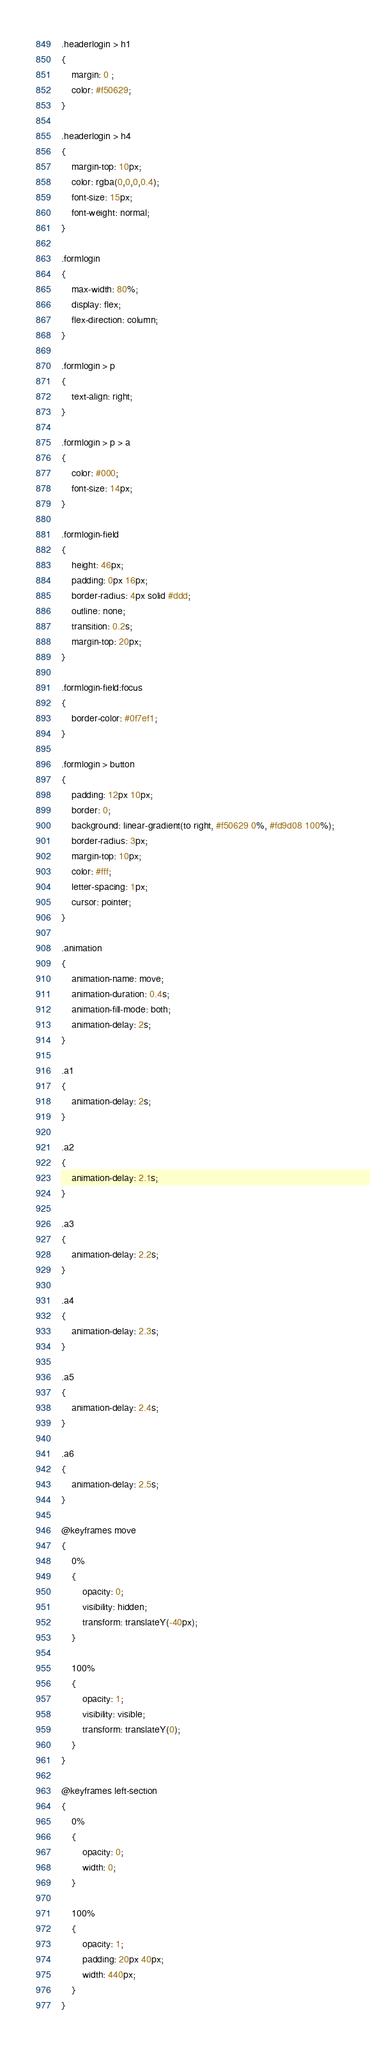<code> <loc_0><loc_0><loc_500><loc_500><_CSS_>.headerlogin > h1
{
    margin: 0 ;
    color: #f50629;
}

.headerlogin > h4 
{
    margin-top: 10px;
    color: rgba(0,0,0,0.4);
    font-size: 15px;
    font-weight: normal;
}

.formlogin
{
    max-width: 80%;
    display: flex;
    flex-direction: column;
}

.formlogin > p
{
    text-align: right;
}

.formlogin > p > a
{
    color: #000;
    font-size: 14px;
}

.formlogin-field
{
    height: 46px;
    padding: 0px 16px;
    border-radius: 4px solid #ddd;
    outline: none;
    transition: 0.2s;
    margin-top: 20px;
}

.formlogin-field:focus
{
    border-color: #0f7ef1;
}

.formlogin > button
{
    padding: 12px 10px;
    border: 0;
    background: linear-gradient(to right, #f50629 0%, #fd9d08 100%);
    border-radius: 3px;
    margin-top: 10px;
    color: #fff;
    letter-spacing: 1px;
    cursor: pointer;
}

.animation
{
    animation-name: move;
    animation-duration: 0.4s;
    animation-fill-mode: both;
    animation-delay: 2s;
}

.a1
{
    animation-delay: 2s;
}

.a2
{
    animation-delay: 2.1s;
}

.a3
{
    animation-delay: 2.2s;
}

.a4
{
    animation-delay: 2.3s;
}

.a5
{
    animation-delay: 2.4s;
}

.a6
{
    animation-delay: 2.5s;
}

@keyframes move 
{
    0%
    {
        opacity: 0;
        visibility: hidden;
        transform: translateY(-40px);
    }

    100%
    {
        opacity: 1;
        visibility: visible;
        transform: translateY(0);
    }
}

@keyframes left-section 
{
    0%
    {
        opacity: 0;
        width: 0;
    }

    100%
    {
        opacity: 1;
        padding: 20px 40px;
        width: 440px;
    }
}</code> 